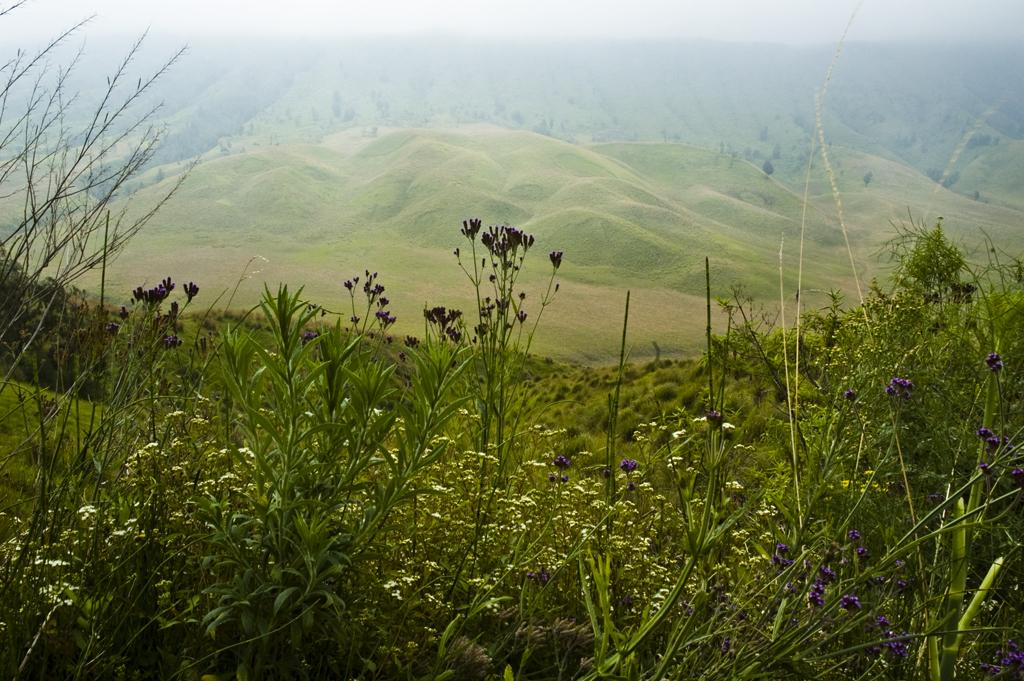What type of plants are present in the image? There are plants with purple flowers in the image. Where are the plants located in the image? The plants are at the bottom of the image. What can be seen in the background of the image? There are hills visible in the image. What is visible above the plants in the image? The sky is visible in the image. What type of friction can be observed between the leaves of the plants in the image? There is no mention of leaves on the plants in the image, and therefore no friction can be observed between them. 